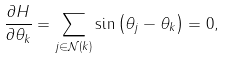Convert formula to latex. <formula><loc_0><loc_0><loc_500><loc_500>\frac { \partial H } { \partial \theta _ { k } } = \sum _ { j \in \mathcal { N } ( k ) } \sin \left ( \theta _ { j } - \theta _ { k } \right ) = 0 ,</formula> 